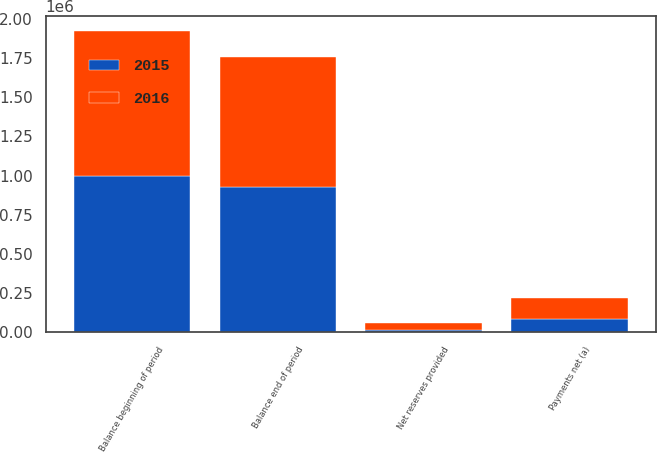<chart> <loc_0><loc_0><loc_500><loc_500><stacked_bar_chart><ecel><fcel>Balance beginning of period<fcel>Net reserves provided<fcel>Payments net (a)<fcel>Balance end of period<nl><fcel>2016<fcel>924563<fcel>40784<fcel>134289<fcel>831058<nl><fcel>2015<fcel>995692<fcel>16085<fcel>87214<fcel>924563<nl></chart> 